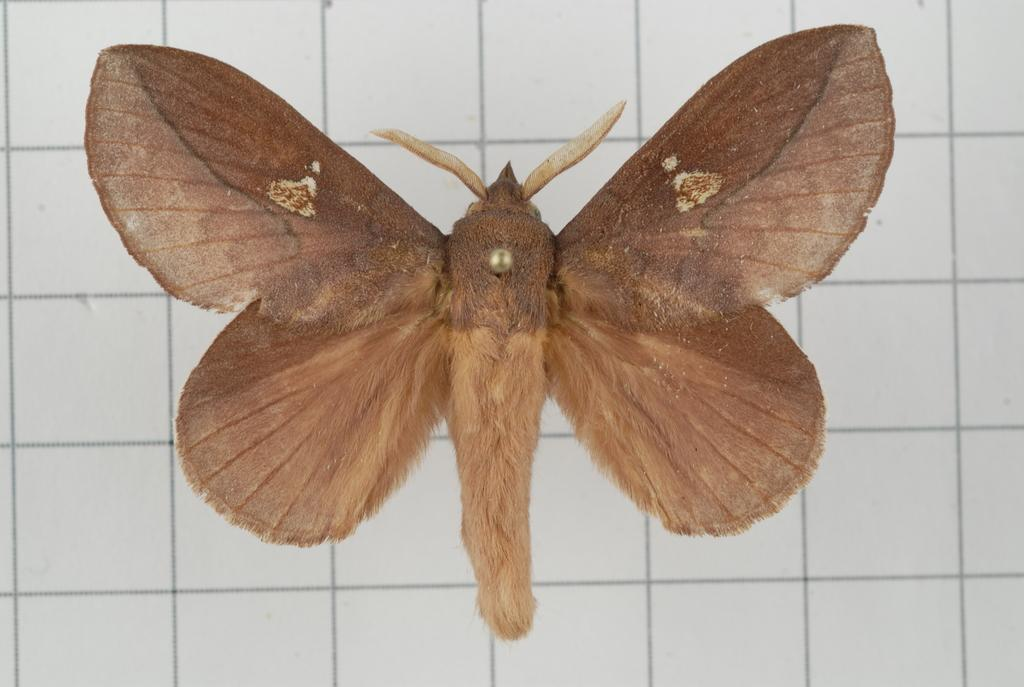What type of creature is present in the image? There is a butterfly in the image. What color is the butterfly? The butterfly is brown in color. What effect does the sneeze have on the goose in the image? There is no goose or sneeze present in the image; it only features a brown butterfly. 